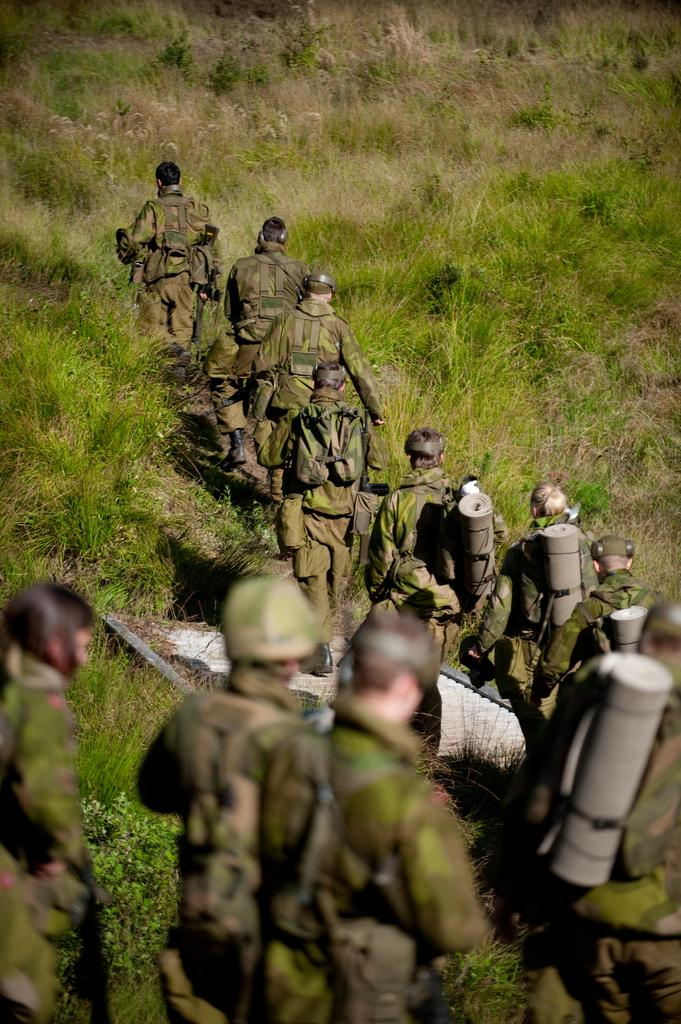Who or what is present in the image? There are people in the image. What are the people wearing on their heads? The people are wearing helmets. What else are some of the people carrying? Some people are wearing backpacks. What is the activity the people are engaged in? The people are walking. What type of terrain can be seen in the image? There is grass visible on the ground. How many hens can be seen in the image? There are no hens present in the image; it features people wearing helmets and walking on grass. What type of fruit is being carried by the people in the image? There is no fruit, specifically apples, being carried by the people in the image. 